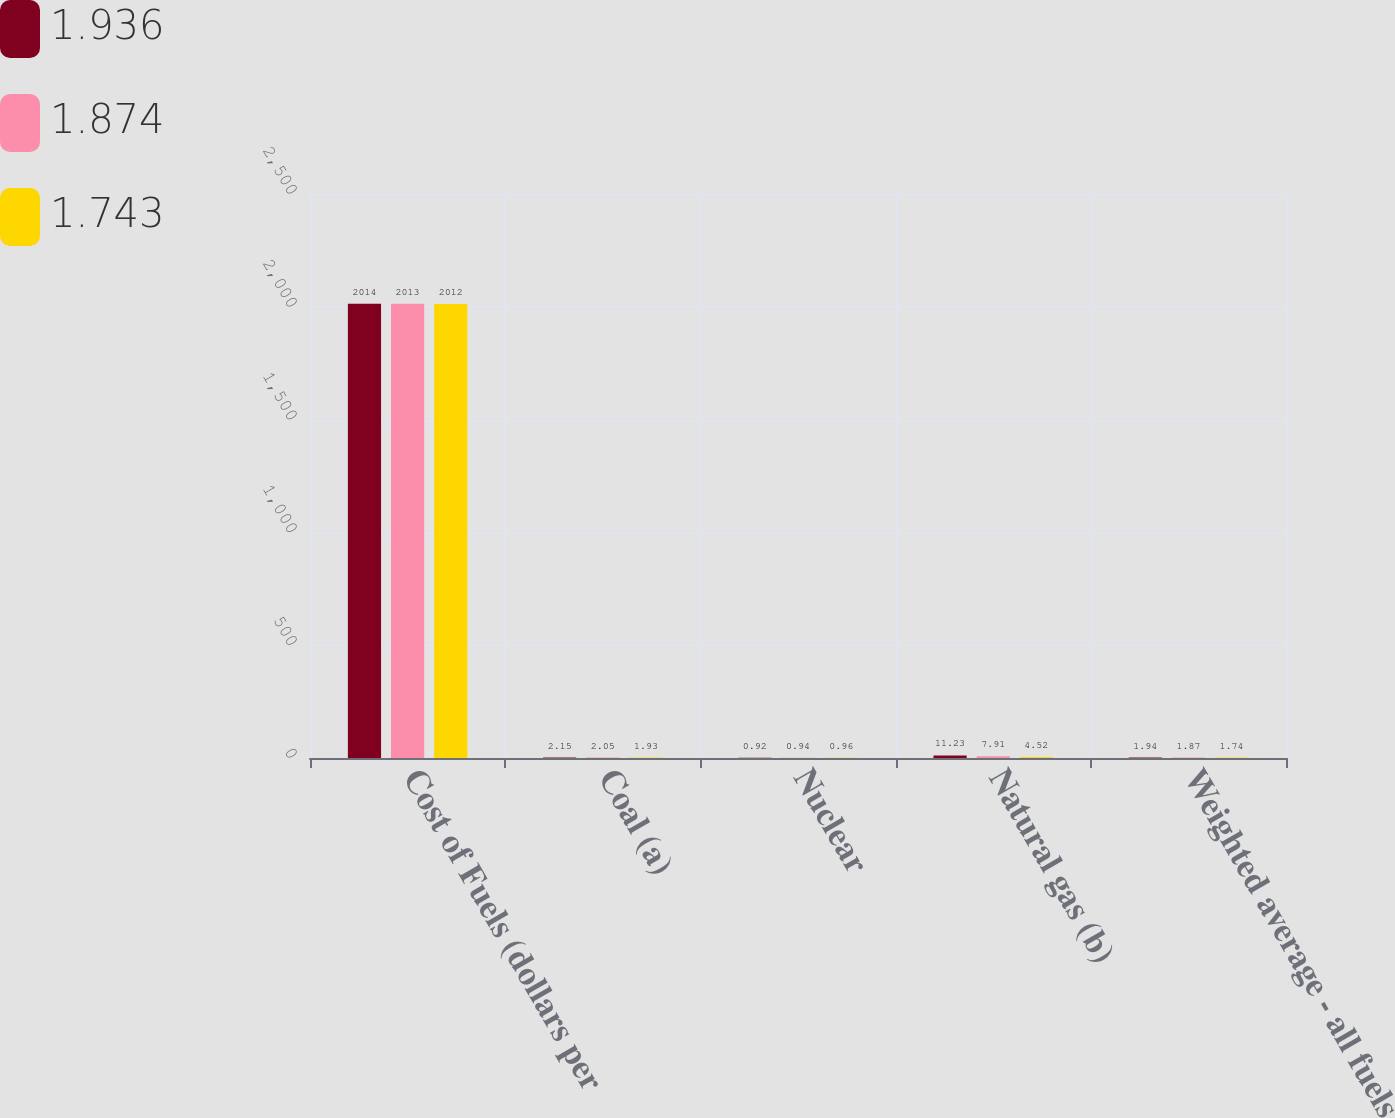Convert chart. <chart><loc_0><loc_0><loc_500><loc_500><stacked_bar_chart><ecel><fcel>Cost of Fuels (dollars per<fcel>Coal (a)<fcel>Nuclear<fcel>Natural gas (b)<fcel>Weighted average - all fuels<nl><fcel>1.936<fcel>2014<fcel>2.15<fcel>0.92<fcel>11.23<fcel>1.94<nl><fcel>1.874<fcel>2013<fcel>2.05<fcel>0.94<fcel>7.91<fcel>1.87<nl><fcel>1.743<fcel>2012<fcel>1.93<fcel>0.96<fcel>4.52<fcel>1.74<nl></chart> 